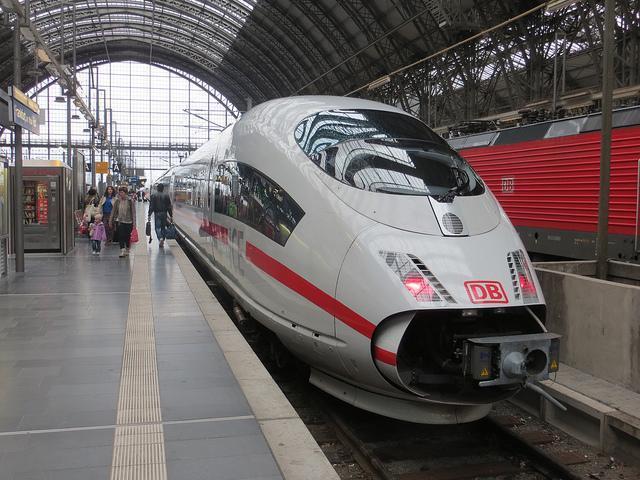How many trains are in the picture?
Give a very brief answer. 1. 